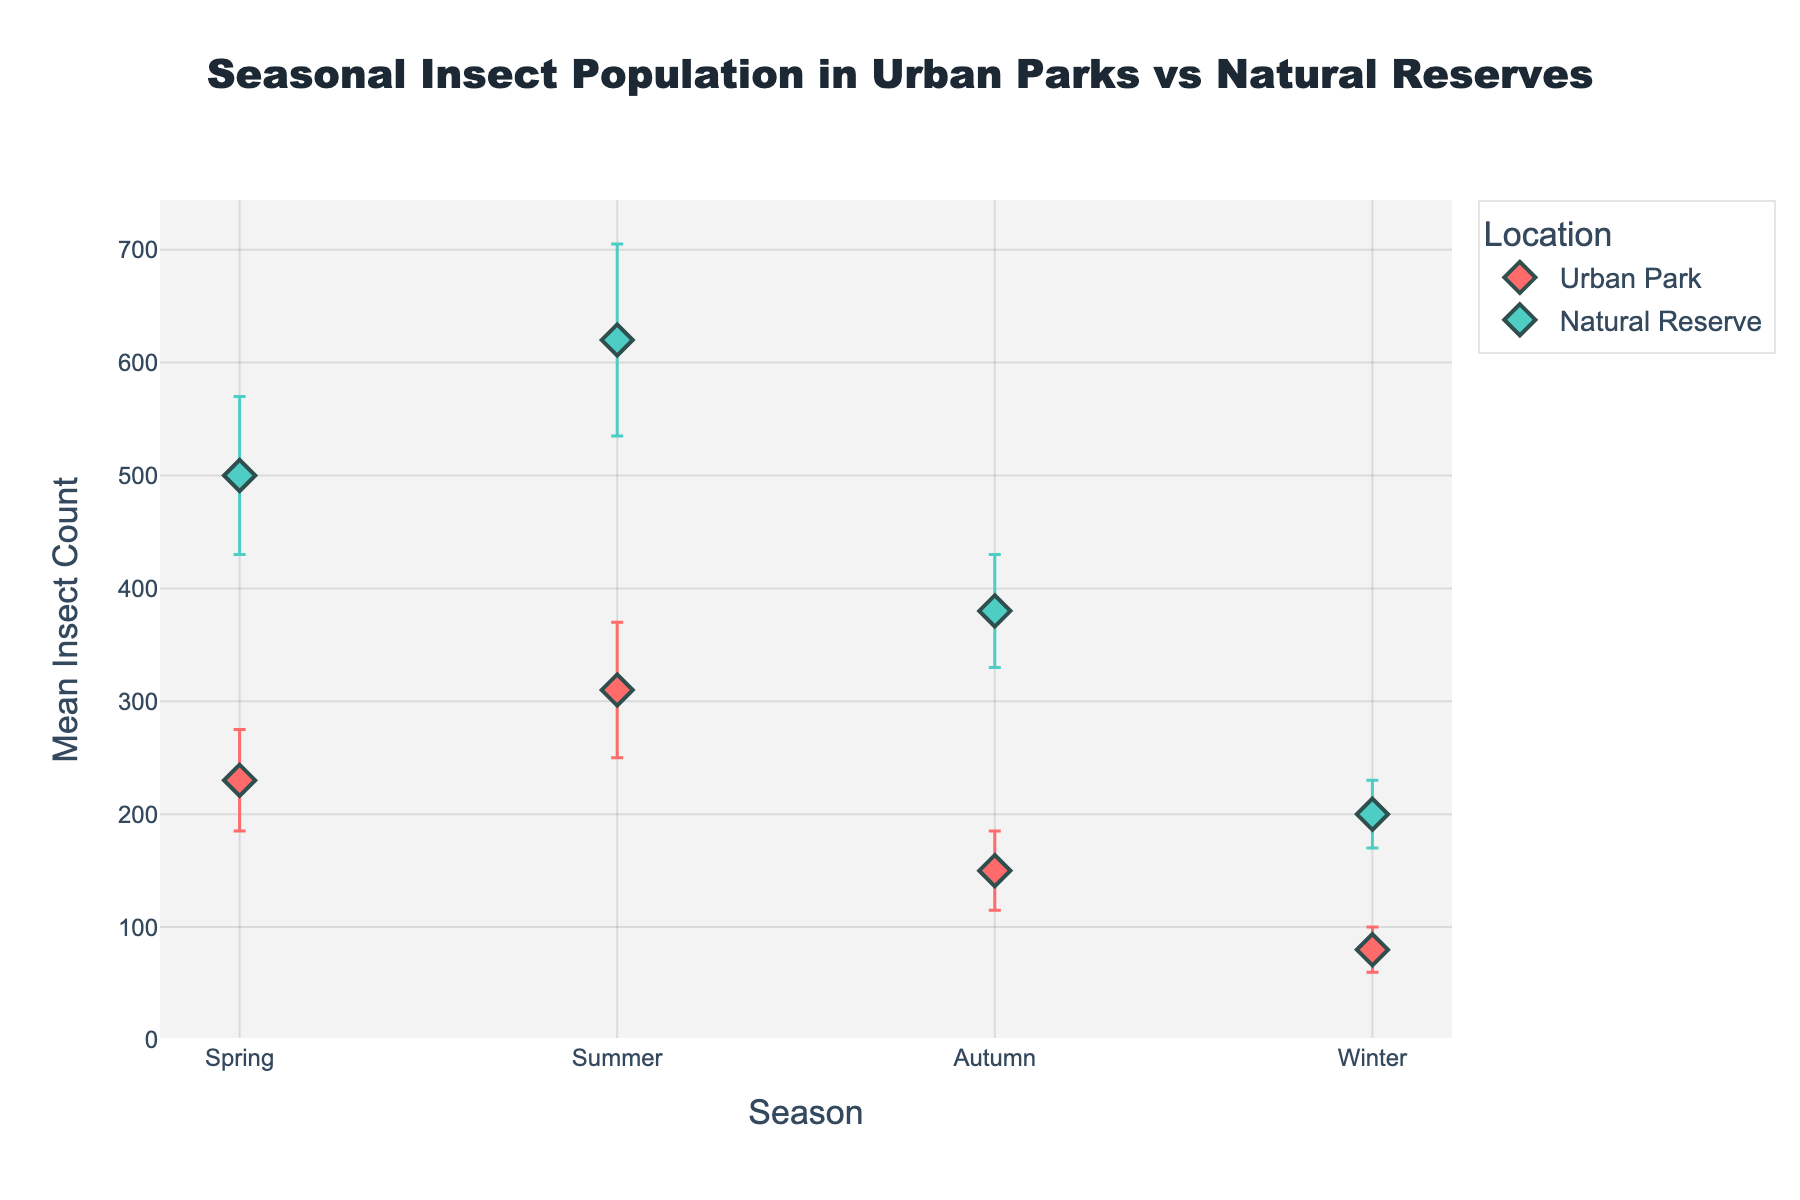What's the title of the plot? The title is located at the top center of the plot and reads "Seasonal Insect Population in Urban Parks vs Natural Reserves".
Answer: Seasonal Insect Population in Urban Parks vs Natural Reserves Which season has the highest mean insect count in urban parks? The highest point on the urban park trace (red markers) indicates that Summer has the highest mean insect count.
Answer: Summer In which location and season is the lowest mean insect count observed? The lowest point on the plot, across both traces, indicates that Winter in Urban Park has the lowest mean insect count.
Answer: Urban Park Winter How does the mean insect count in Natural Reserves during Spring compare to Urban Parks during the same season? Comparing the values for Spring, the mean insect count in Natural Reserves (500) is more than twice the count in Urban Parks (230).
Answer: Natural Reserves is higher What is the overall trend of mean insect counts across seasons for Urban Parks? Observing the red markers for Urban Park, the trend shows a decrease from Summer to Winter, indicating a decline across these seasons.
Answer: Decreasing Which location shows a greater variation in insect count across all seasons? By comparing the range of means and standard deviations, Natural Reserves show higher values and thus a greater variation in insect count across all seasons.
Answer: Natural Reserves What is the mean insect count in Natural Reserves during Autumn, and what are the error bars' ranges? The plot's green marker for Natural Reserves in Autumn shows a mean insect count of 380 with a standard deviation of 50. The error bars range from 330 to 430.
Answer: 380, error bars from 330 to 430 Are there any seasons where the mean insect count in Urban Parks and Natural Reserves is roughly the same? There are no overlapping values or close mean counts for any seasons between the two locations; all counts in Natural Reserves are consistently higher.
Answer: No How does the standard deviation in Summer compare between Urban Parks and Natural Reserves? The error bars indicate that the standard deviation for Urban Parks is 60 while for Natural Reserves it is 85, hence Natural Reserves has a larger standard deviation in Summer.
Answer: Natural Reserves is larger In which season do Urban Parks exhibit the smallest error margin, and what might this suggest about insect population stability? The smallest error margins can be seen in Winter for Urban Parks, indicating the lowest standard deviation (20), which suggests higher stability in insect population during this season.
Answer: Winter 